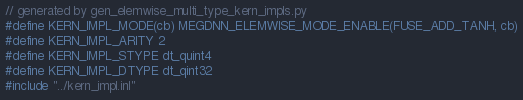Convert code to text. <code><loc_0><loc_0><loc_500><loc_500><_Cuda_>// generated by gen_elemwise_multi_type_kern_impls.py
#define KERN_IMPL_MODE(cb) MEGDNN_ELEMWISE_MODE_ENABLE(FUSE_ADD_TANH, cb)
#define KERN_IMPL_ARITY 2
#define KERN_IMPL_STYPE dt_quint4
#define KERN_IMPL_DTYPE dt_qint32
#include "../kern_impl.inl"
</code> 